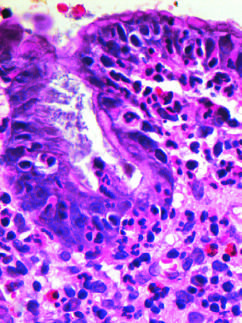re histologic appearance in active takayasu aortitis illustrating destruction and fibrosis of the arterial media prominent?
Answer the question using a single word or phrase. No 